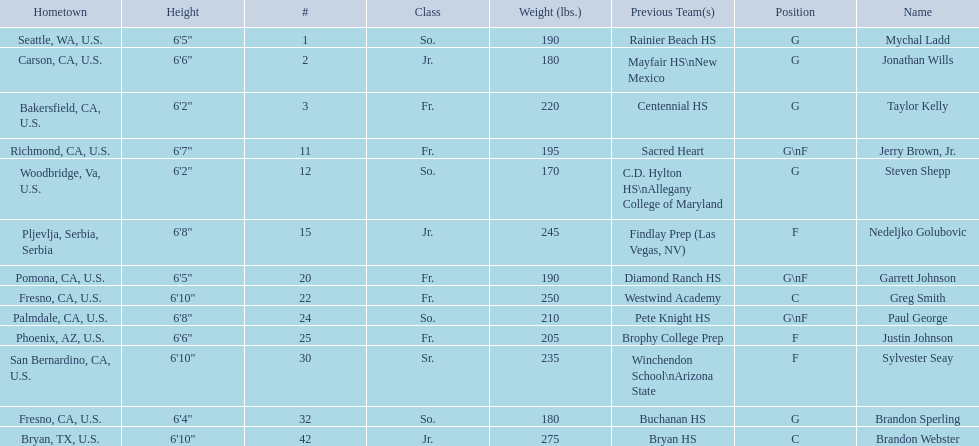Which positions are so.? G, G, G\nF, G. Which weights are g 190, 170, 180. What height is under 6 3' 6'2". What is the name Steven Shepp. 